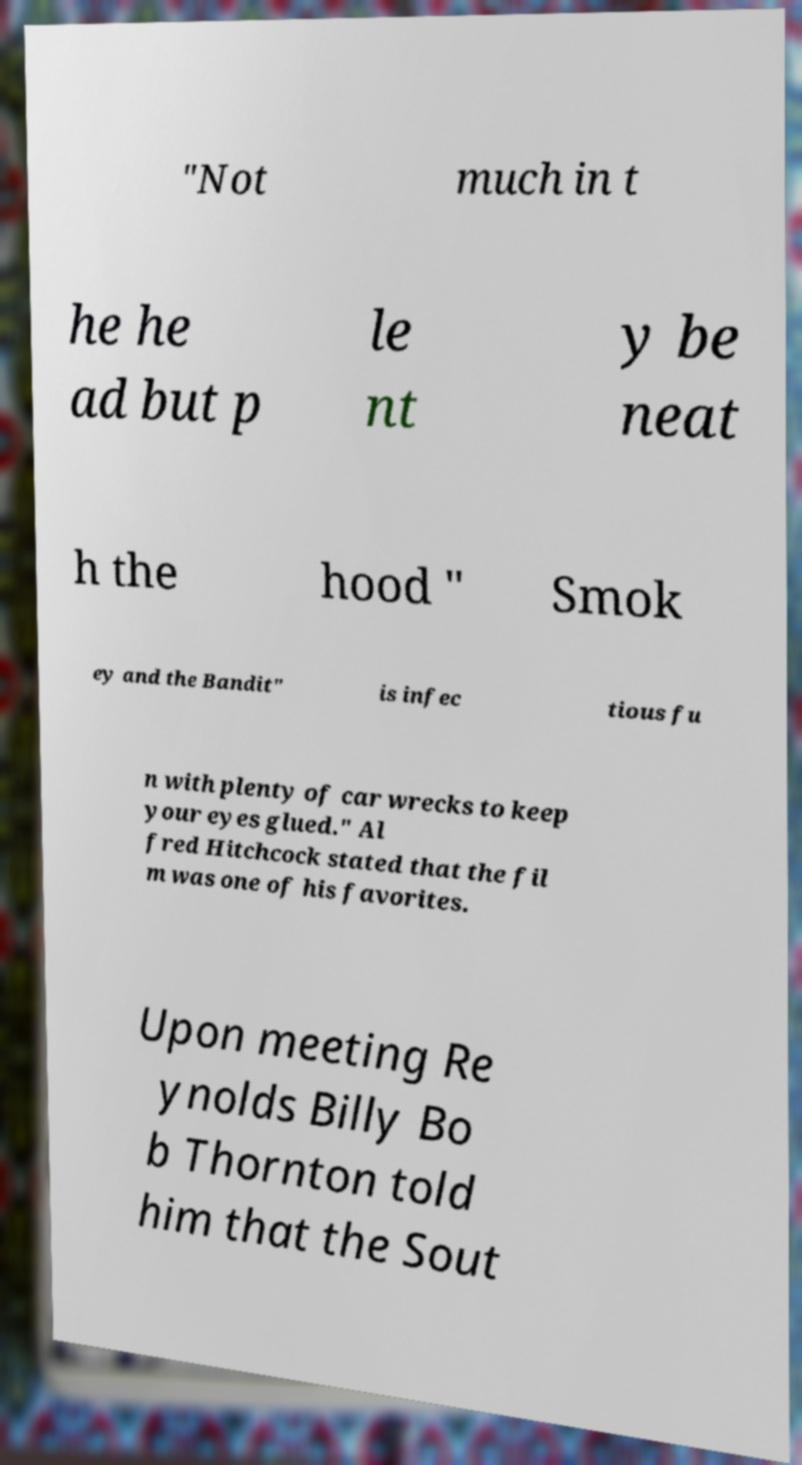What messages or text are displayed in this image? I need them in a readable, typed format. "Not much in t he he ad but p le nt y be neat h the hood " Smok ey and the Bandit" is infec tious fu n with plenty of car wrecks to keep your eyes glued." Al fred Hitchcock stated that the fil m was one of his favorites. Upon meeting Re ynolds Billy Bo b Thornton told him that the Sout 